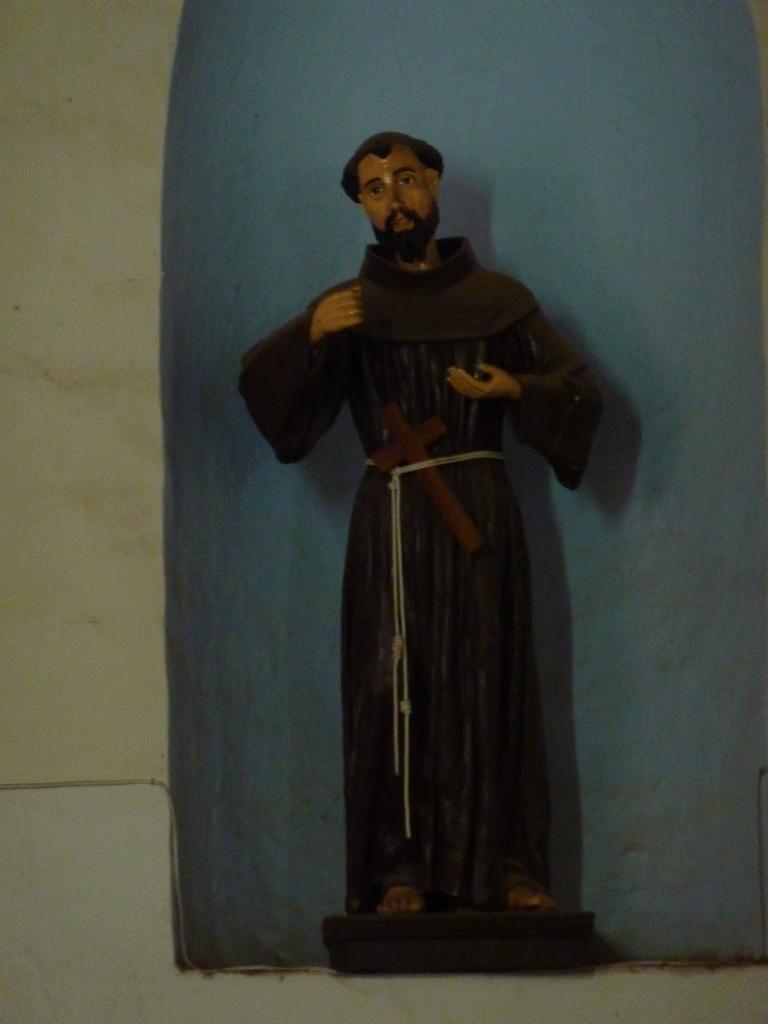Could you give a brief overview of what you see in this image? In this image I can see the person's statue in black and brown color. Background is in blue, white and cream color. 